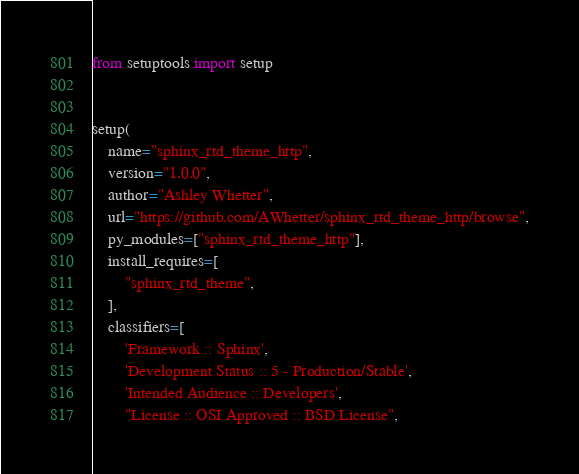<code> <loc_0><loc_0><loc_500><loc_500><_Python_>from setuptools import setup


setup(
    name="sphinx_rtd_theme_http",
    version="1.0.0",
    author="Ashley Whetter",
    url="https://github.com/AWhetter/sphinx_rtd_theme_http/browse",
    py_modules=["sphinx_rtd_theme_http"],
    install_requires=[
        "sphinx_rtd_theme",
    ],
    classifiers=[
        'Framework :: Sphinx',
        'Development Status :: 5 - Production/Stable',
        'Intended Audience :: Developers',
        "License :: OSI Approved :: BSD License",</code> 